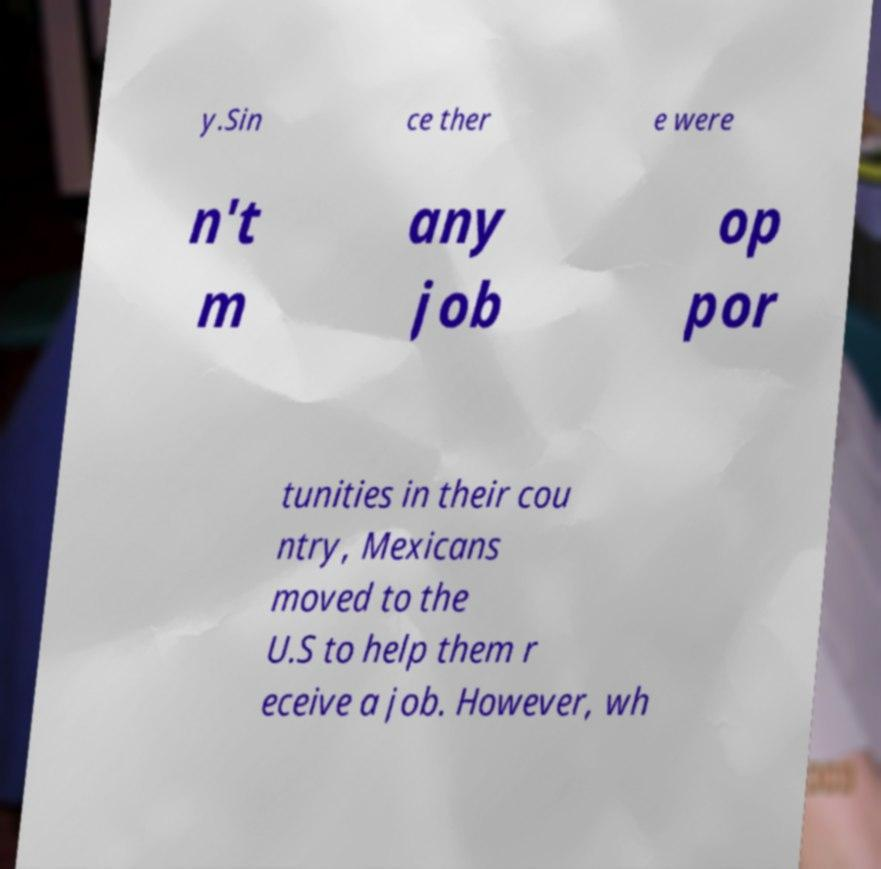Could you extract and type out the text from this image? y.Sin ce ther e were n't m any job op por tunities in their cou ntry, Mexicans moved to the U.S to help them r eceive a job. However, wh 